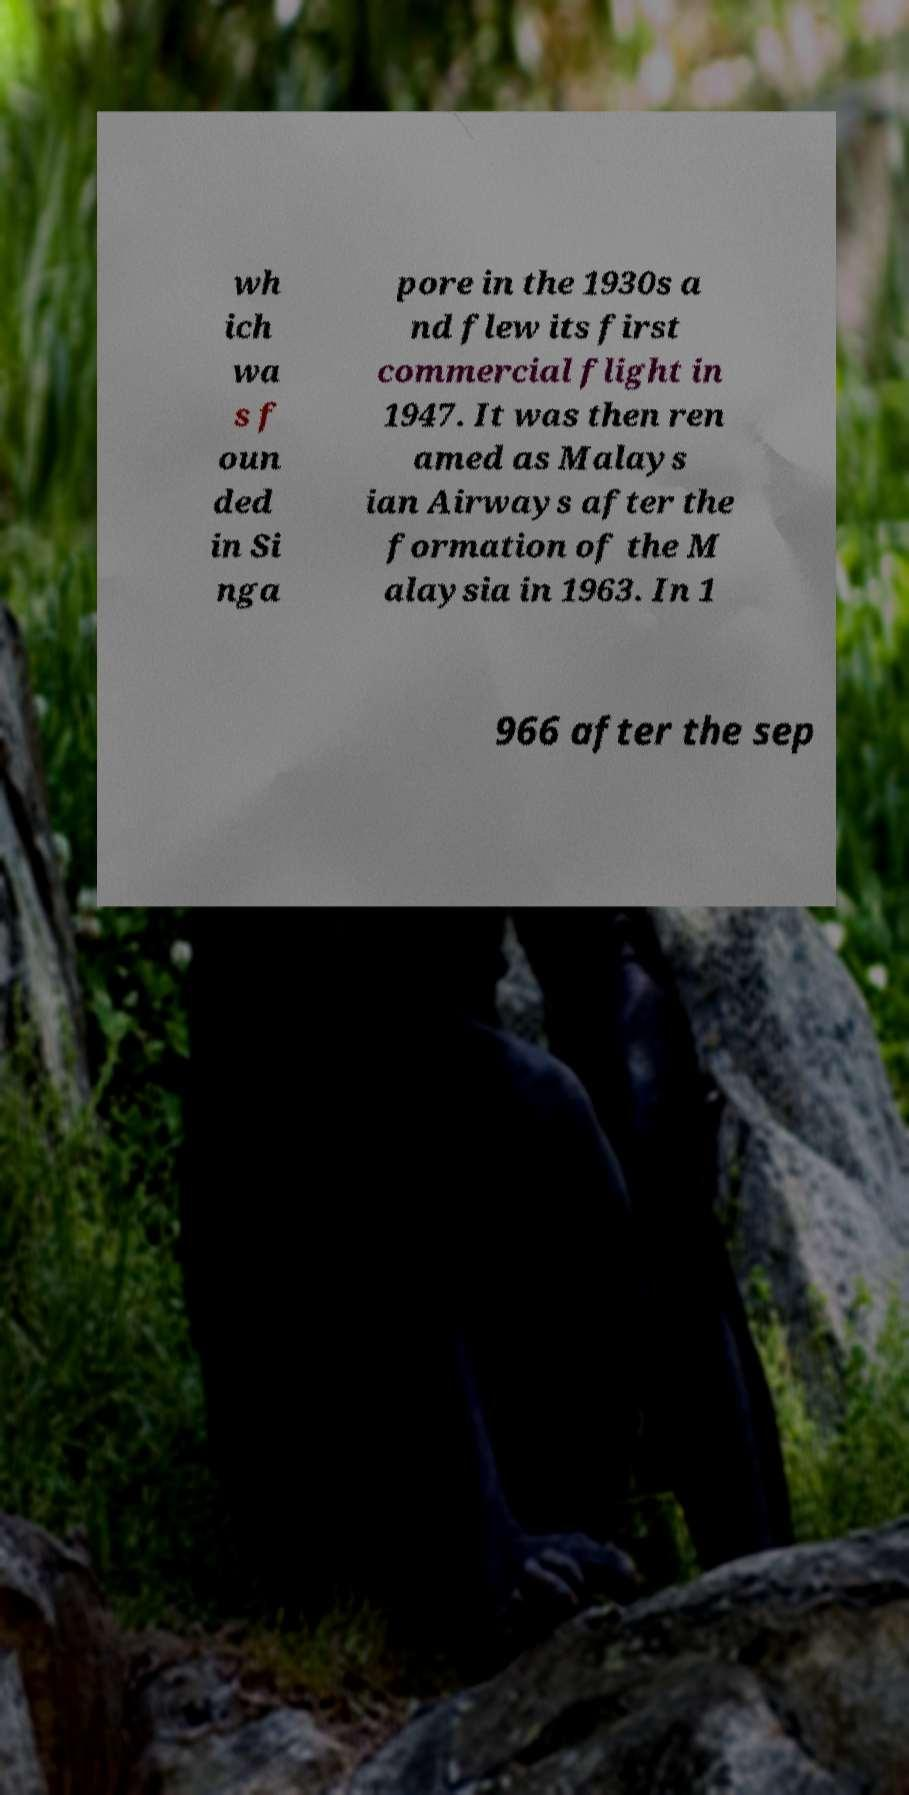Could you extract and type out the text from this image? wh ich wa s f oun ded in Si nga pore in the 1930s a nd flew its first commercial flight in 1947. It was then ren amed as Malays ian Airways after the formation of the M alaysia in 1963. In 1 966 after the sep 